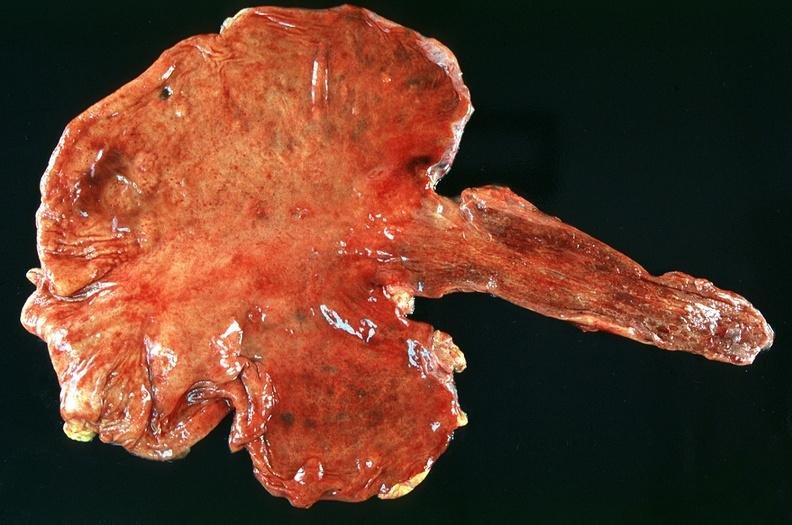s gastrointestinal present?
Answer the question using a single word or phrase. Yes 